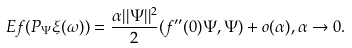Convert formula to latex. <formula><loc_0><loc_0><loc_500><loc_500>E f ( P _ { \Psi } \xi ( \omega ) ) = \frac { \alpha | | \Psi | | ^ { 2 } } { 2 } ( f ^ { \prime \prime } ( 0 ) \Psi , \Psi ) + o ( \alpha ) , \alpha \to 0 .</formula> 